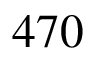Convert formula to latex. <formula><loc_0><loc_0><loc_500><loc_500>4 7 0</formula> 